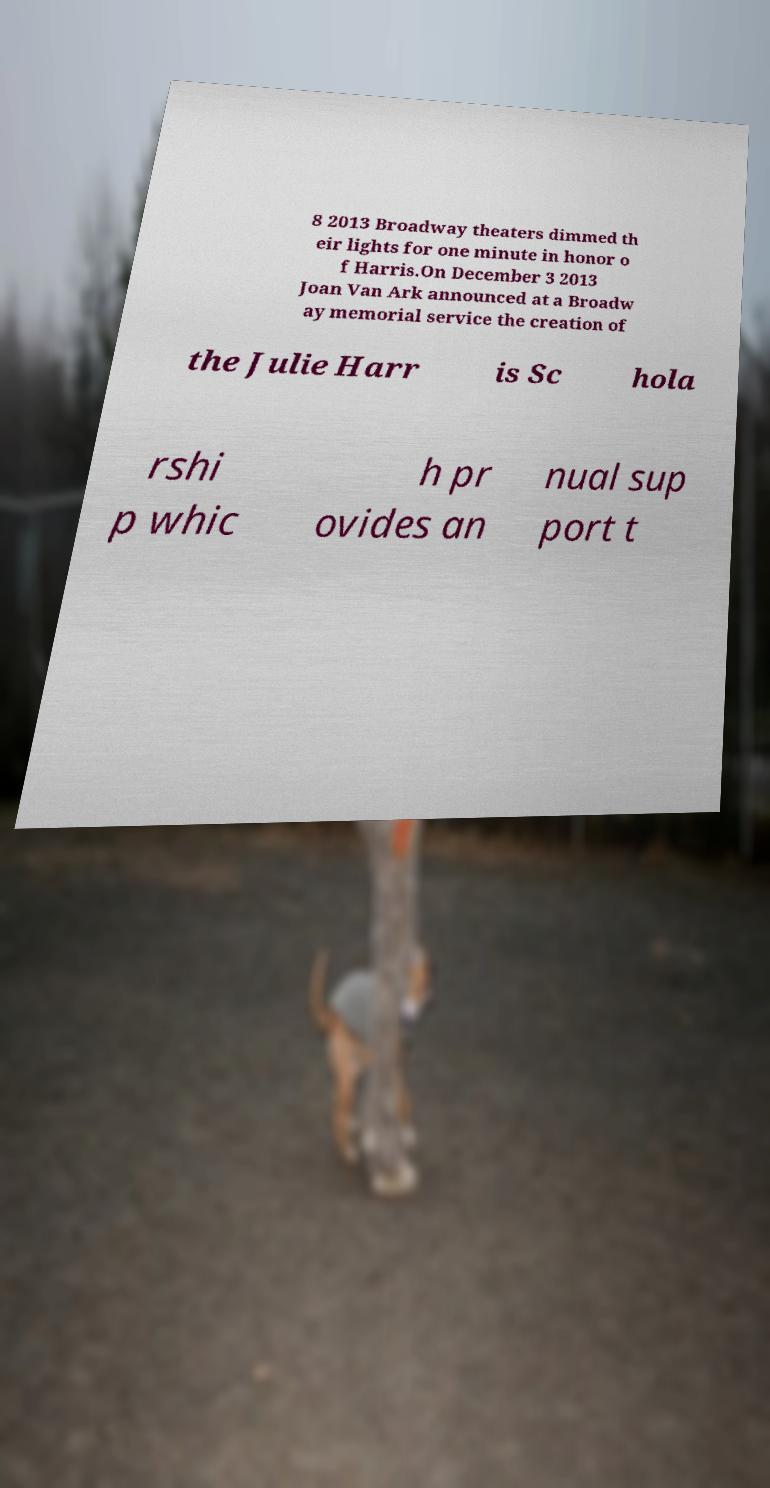I need the written content from this picture converted into text. Can you do that? 8 2013 Broadway theaters dimmed th eir lights for one minute in honor o f Harris.On December 3 2013 Joan Van Ark announced at a Broadw ay memorial service the creation of the Julie Harr is Sc hola rshi p whic h pr ovides an nual sup port t 